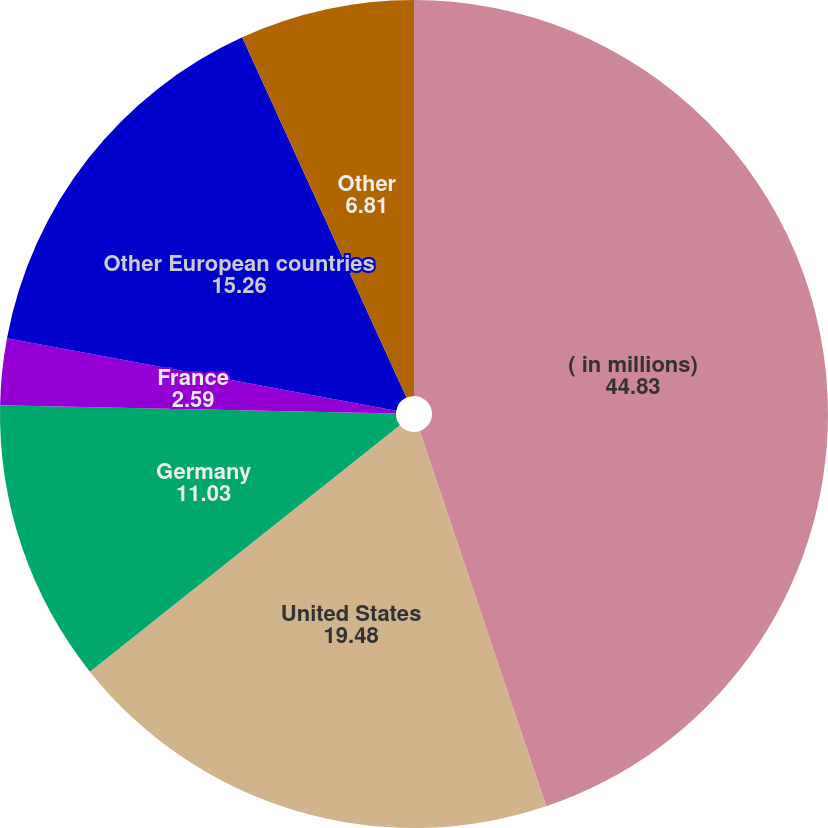Convert chart to OTSL. <chart><loc_0><loc_0><loc_500><loc_500><pie_chart><fcel>( in millions)<fcel>United States<fcel>Germany<fcel>France<fcel>Other European countries<fcel>Other<nl><fcel>44.83%<fcel>19.48%<fcel>11.03%<fcel>2.59%<fcel>15.26%<fcel>6.81%<nl></chart> 